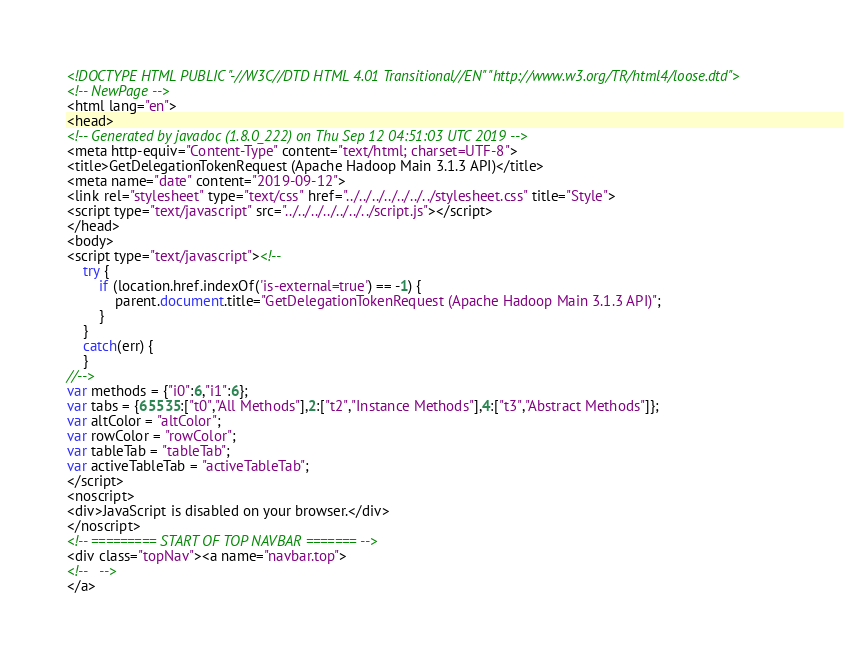<code> <loc_0><loc_0><loc_500><loc_500><_HTML_><!DOCTYPE HTML PUBLIC "-//W3C//DTD HTML 4.01 Transitional//EN" "http://www.w3.org/TR/html4/loose.dtd">
<!-- NewPage -->
<html lang="en">
<head>
<!-- Generated by javadoc (1.8.0_222) on Thu Sep 12 04:51:03 UTC 2019 -->
<meta http-equiv="Content-Type" content="text/html; charset=UTF-8">
<title>GetDelegationTokenRequest (Apache Hadoop Main 3.1.3 API)</title>
<meta name="date" content="2019-09-12">
<link rel="stylesheet" type="text/css" href="../../../../../../../stylesheet.css" title="Style">
<script type="text/javascript" src="../../../../../../../script.js"></script>
</head>
<body>
<script type="text/javascript"><!--
    try {
        if (location.href.indexOf('is-external=true') == -1) {
            parent.document.title="GetDelegationTokenRequest (Apache Hadoop Main 3.1.3 API)";
        }
    }
    catch(err) {
    }
//-->
var methods = {"i0":6,"i1":6};
var tabs = {65535:["t0","All Methods"],2:["t2","Instance Methods"],4:["t3","Abstract Methods"]};
var altColor = "altColor";
var rowColor = "rowColor";
var tableTab = "tableTab";
var activeTableTab = "activeTableTab";
</script>
<noscript>
<div>JavaScript is disabled on your browser.</div>
</noscript>
<!-- ========= START OF TOP NAVBAR ======= -->
<div class="topNav"><a name="navbar.top">
<!--   -->
</a></code> 